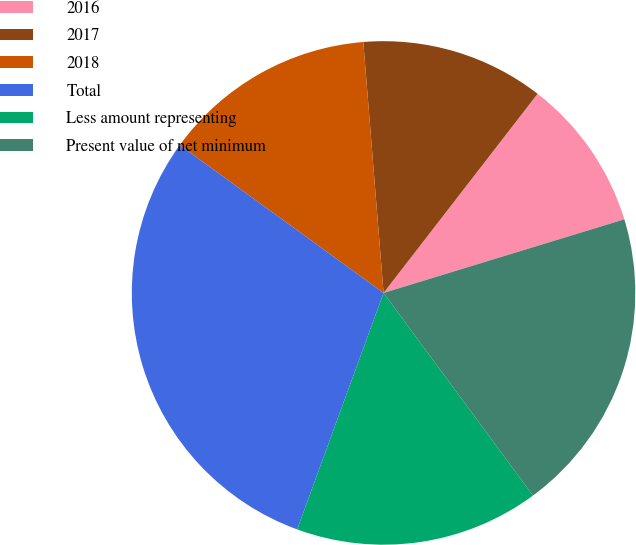Convert chart to OTSL. <chart><loc_0><loc_0><loc_500><loc_500><pie_chart><fcel>2016<fcel>2017<fcel>2018<fcel>Total<fcel>Less amount representing<fcel>Present value of net minimum<nl><fcel>9.8%<fcel>11.76%<fcel>13.73%<fcel>29.41%<fcel>15.69%<fcel>19.61%<nl></chart> 